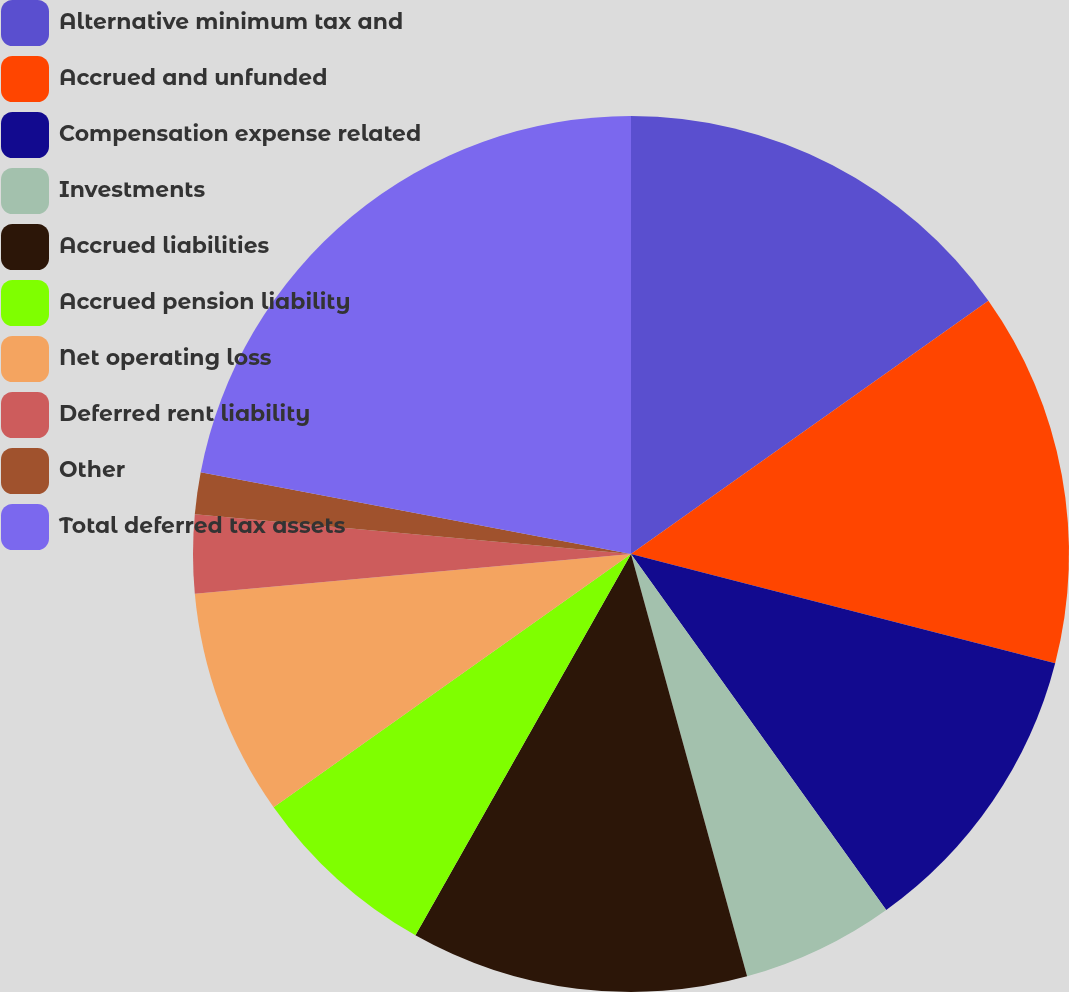Convert chart. <chart><loc_0><loc_0><loc_500><loc_500><pie_chart><fcel>Alternative minimum tax and<fcel>Accrued and unfunded<fcel>Compensation expense related<fcel>Investments<fcel>Accrued liabilities<fcel>Accrued pension liability<fcel>Net operating loss<fcel>Deferred rent liability<fcel>Other<fcel>Total deferred tax assets<nl><fcel>15.19%<fcel>13.82%<fcel>11.09%<fcel>5.63%<fcel>12.46%<fcel>7.0%<fcel>8.36%<fcel>2.9%<fcel>1.54%<fcel>22.01%<nl></chart> 